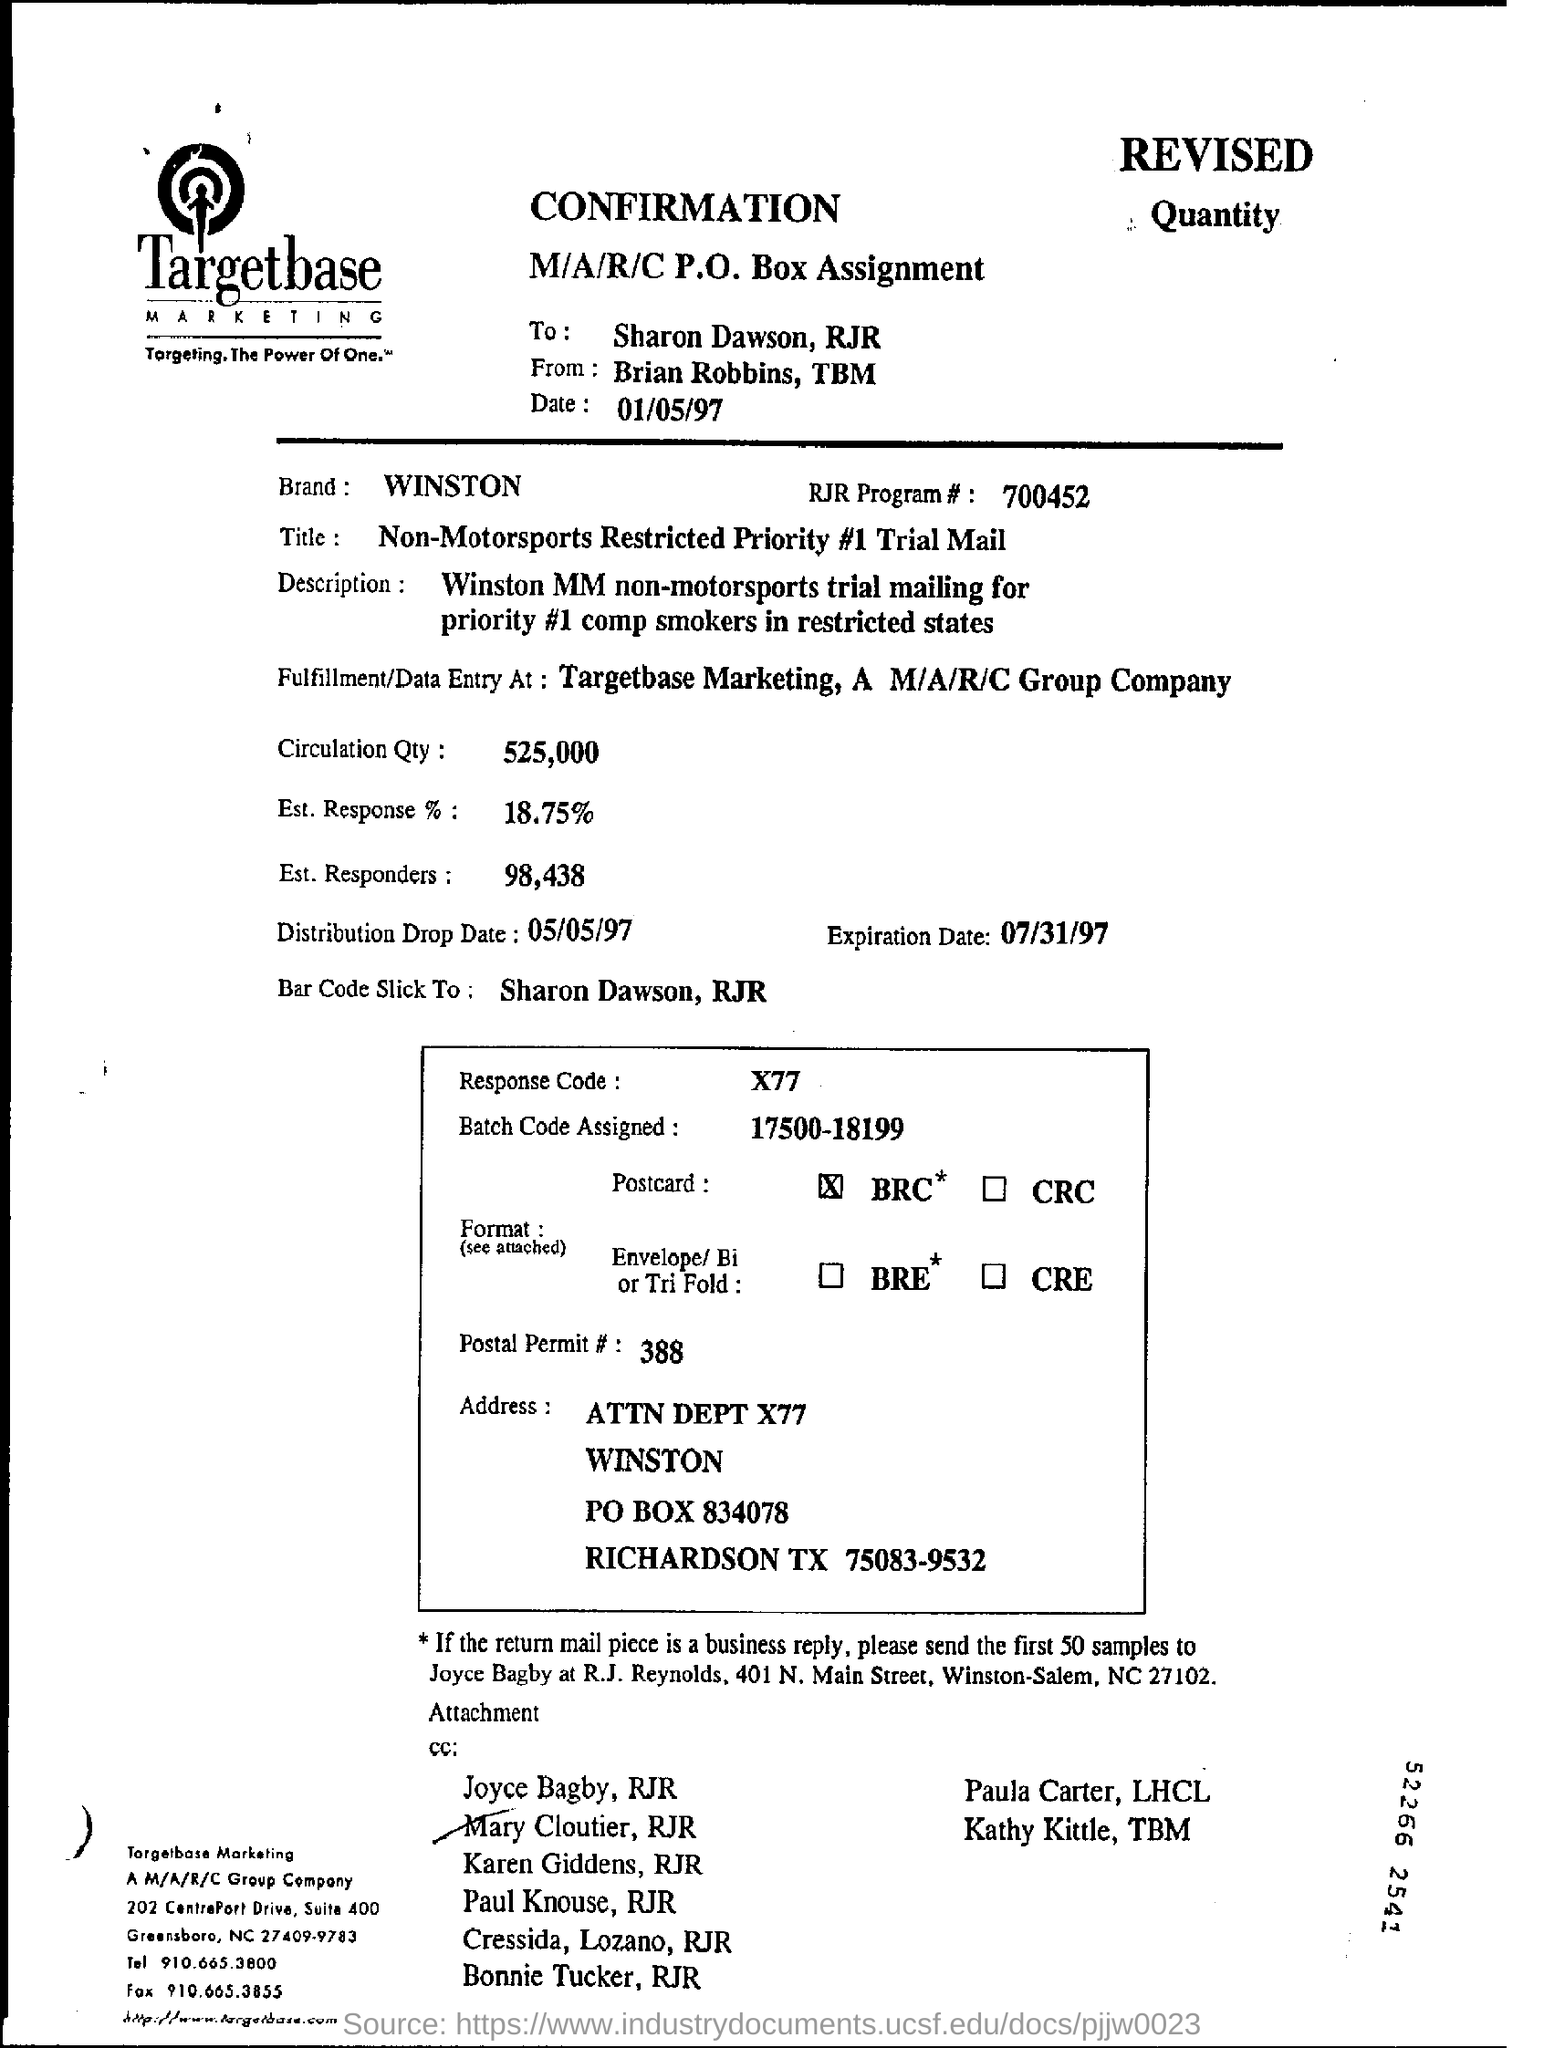What is the heading of the document?
Your response must be concise. CONFIRMATION. What is the Brand mentioned?
Make the answer very short. WINSTON. What is the Distribution Drop Date?
Offer a very short reply. 05/05/97. What is the Expiration Date?
Offer a terse response. 07/31/97. 